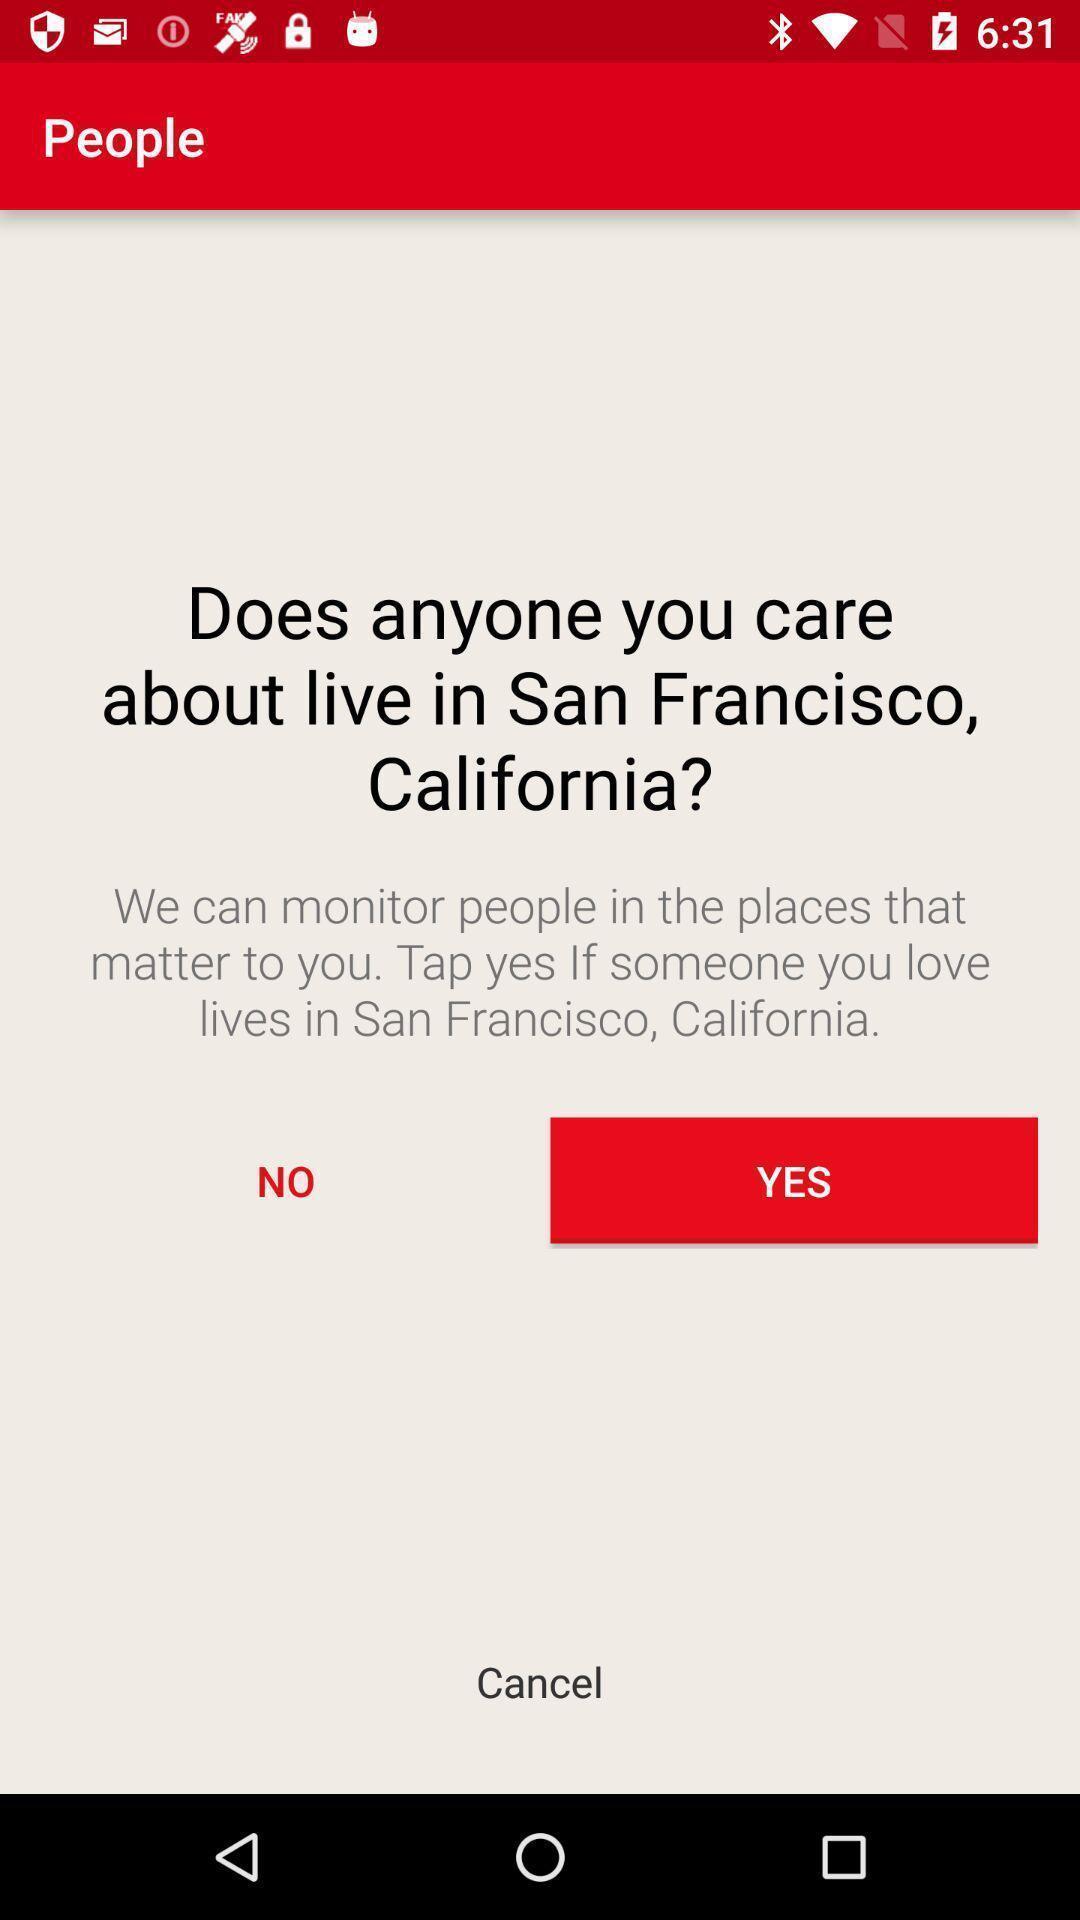Please provide a description for this image. Screen shows anyone you care live in san francisco. 